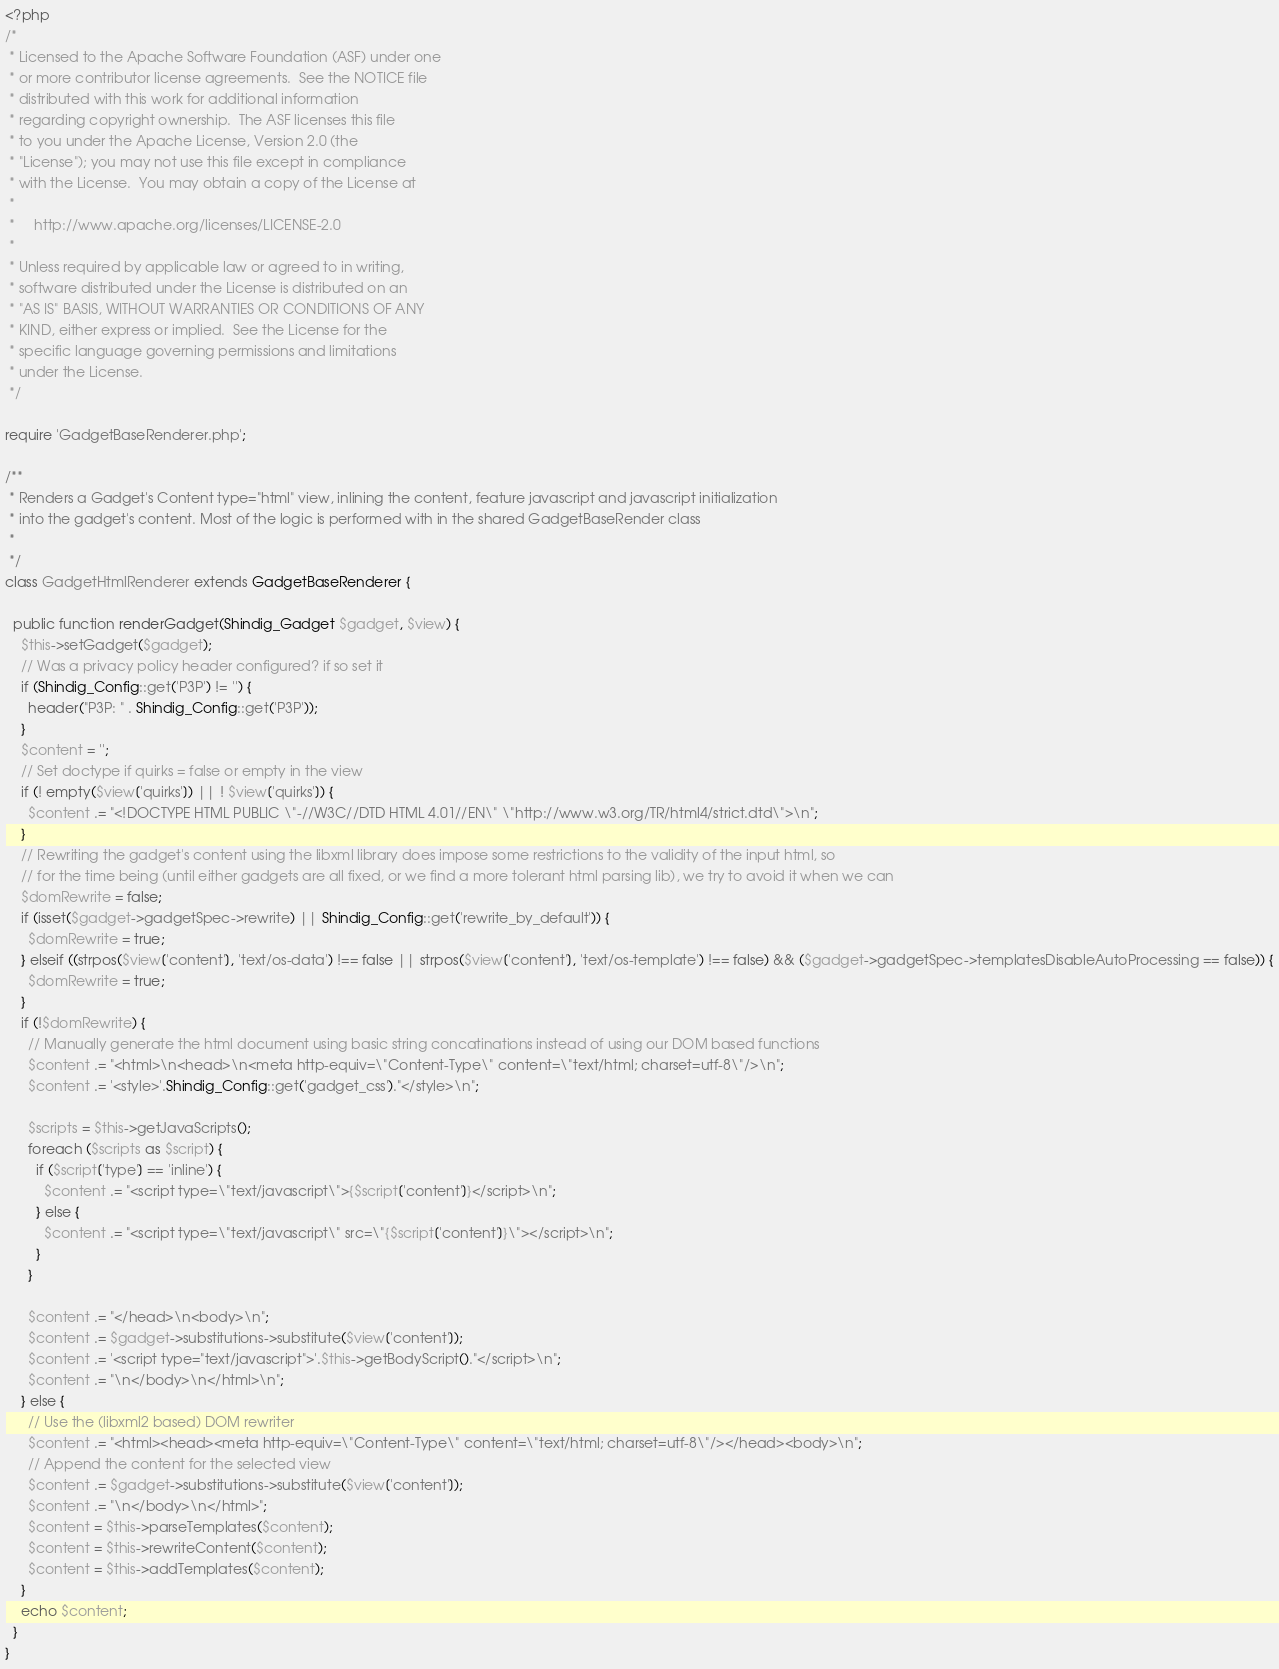<code> <loc_0><loc_0><loc_500><loc_500><_PHP_><?php
/*
 * Licensed to the Apache Software Foundation (ASF) under one
 * or more contributor license agreements.  See the NOTICE file
 * distributed with this work for additional information
 * regarding copyright ownership.  The ASF licenses this file
 * to you under the Apache License, Version 2.0 (the
 * "License"); you may not use this file except in compliance
 * with the License.  You may obtain a copy of the License at
 *
 *     http://www.apache.org/licenses/LICENSE-2.0
 *
 * Unless required by applicable law or agreed to in writing,
 * software distributed under the License is distributed on an
 * "AS IS" BASIS, WITHOUT WARRANTIES OR CONDITIONS OF ANY
 * KIND, either express or implied.  See the License for the
 * specific language governing permissions and limitations
 * under the License.
 */

require 'GadgetBaseRenderer.php';

/**
 * Renders a Gadget's Content type="html" view, inlining the content, feature javascript and javascript initialization
 * into the gadget's content. Most of the logic is performed with in the shared GadgetBaseRender class
 *
 */
class GadgetHtmlRenderer extends GadgetBaseRenderer {

  public function renderGadget(Shindig_Gadget $gadget, $view) {
    $this->setGadget($gadget);
    // Was a privacy policy header configured? if so set it
    if (Shindig_Config::get('P3P') != '') {
      header("P3P: " . Shindig_Config::get('P3P'));
    }
    $content = '';
    // Set doctype if quirks = false or empty in the view
    if (! empty($view['quirks']) || ! $view['quirks']) {
      $content .= "<!DOCTYPE HTML PUBLIC \"-//W3C//DTD HTML 4.01//EN\" \"http://www.w3.org/TR/html4/strict.dtd\">\n";
    }
    // Rewriting the gadget's content using the libxml library does impose some restrictions to the validity of the input html, so
    // for the time being (until either gadgets are all fixed, or we find a more tolerant html parsing lib), we try to avoid it when we can
    $domRewrite = false;
    if (isset($gadget->gadgetSpec->rewrite) || Shindig_Config::get('rewrite_by_default')) {
      $domRewrite = true;
    } elseif ((strpos($view['content'], 'text/os-data') !== false || strpos($view['content'], 'text/os-template') !== false) && ($gadget->gadgetSpec->templatesDisableAutoProcessing == false)) {
      $domRewrite = true;
    }
    if (!$domRewrite) {
      // Manually generate the html document using basic string concatinations instead of using our DOM based functions
      $content .= "<html>\n<head>\n<meta http-equiv=\"Content-Type\" content=\"text/html; charset=utf-8\"/>\n";
      $content .= '<style>'.Shindig_Config::get('gadget_css')."</style>\n";

      $scripts = $this->getJavaScripts();
      foreach ($scripts as $script) {
        if ($script['type'] == 'inline') {
          $content .= "<script type=\"text/javascript\">{$script['content']}</script>\n";
        } else {
          $content .= "<script type=\"text/javascript\" src=\"{$script['content']}\"></script>\n";
        }
      }

      $content .= "</head>\n<body>\n";
      $content .= $gadget->substitutions->substitute($view['content']);
      $content .= '<script type="text/javascript">'.$this->getBodyScript()."</script>\n";
      $content .= "\n</body>\n</html>\n";
    } else {
      // Use the (libxml2 based) DOM rewriter
      $content .= "<html><head><meta http-equiv=\"Content-Type\" content=\"text/html; charset=utf-8\"/></head><body>\n";
      // Append the content for the selected view
      $content .= $gadget->substitutions->substitute($view['content']);
      $content .= "\n</body>\n</html>";
      $content = $this->parseTemplates($content);
      $content = $this->rewriteContent($content);
      $content = $this->addTemplates($content);
    }
    echo $content;
  }
}
</code> 